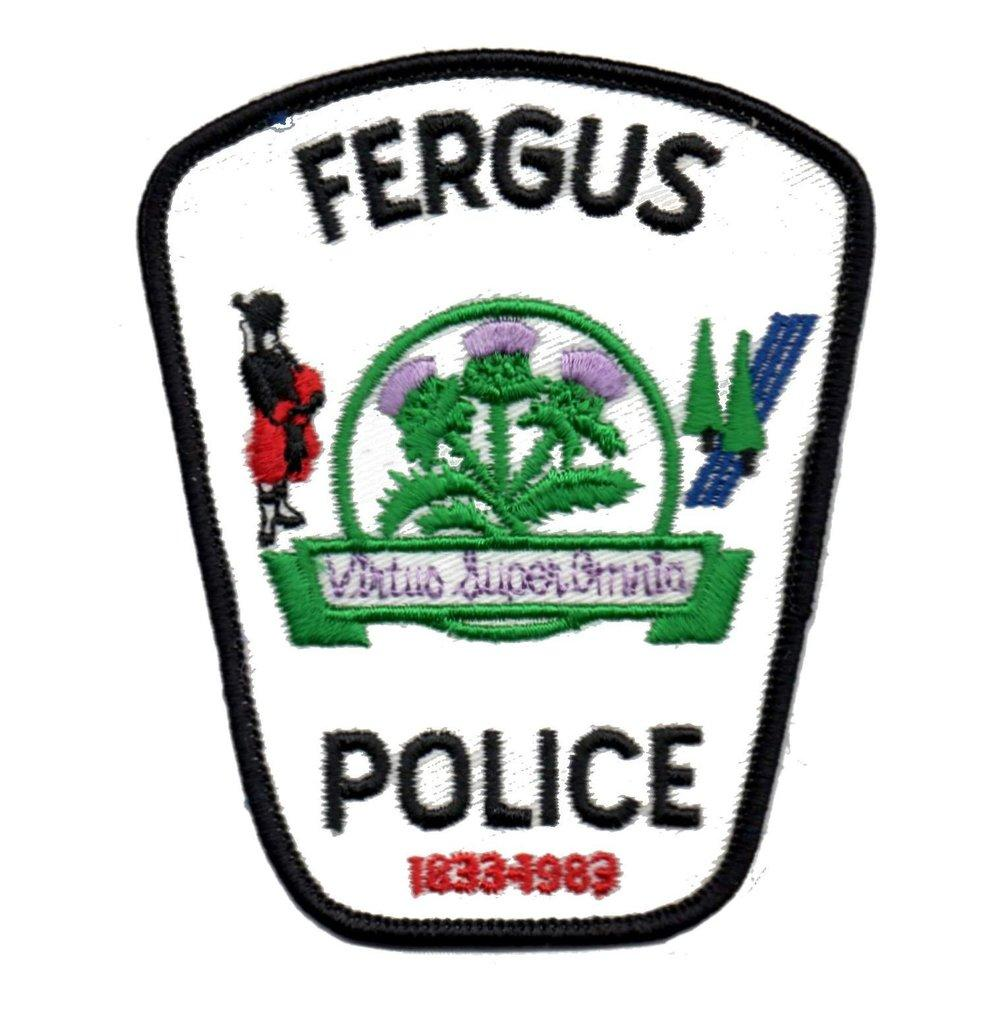What is the main feature of the image? There is a logo in the image. What information does the logo contain? The logo contains a name. What type of natural environment is visible in the image? There are trees in the image. Who or what is present in the image? There is a person in the image. What type of man-made structure can be seen in the image? There is a road in the image. What is the weight of the boy in the image? There is no boy present in the image, so it is not possible to determine the weight. 